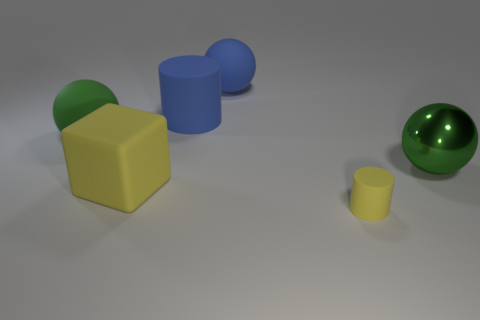Subtract all big blue matte balls. How many balls are left? 2 Add 2 big matte cylinders. How many objects exist? 8 Subtract all green spheres. How many spheres are left? 1 Add 2 objects. How many objects are left? 8 Add 5 big blue rubber things. How many big blue rubber things exist? 7 Subtract 1 yellow cylinders. How many objects are left? 5 Subtract all cubes. How many objects are left? 5 Subtract 1 cylinders. How many cylinders are left? 1 Subtract all blue blocks. Subtract all yellow balls. How many blocks are left? 1 Subtract all blue cylinders. How many purple cubes are left? 0 